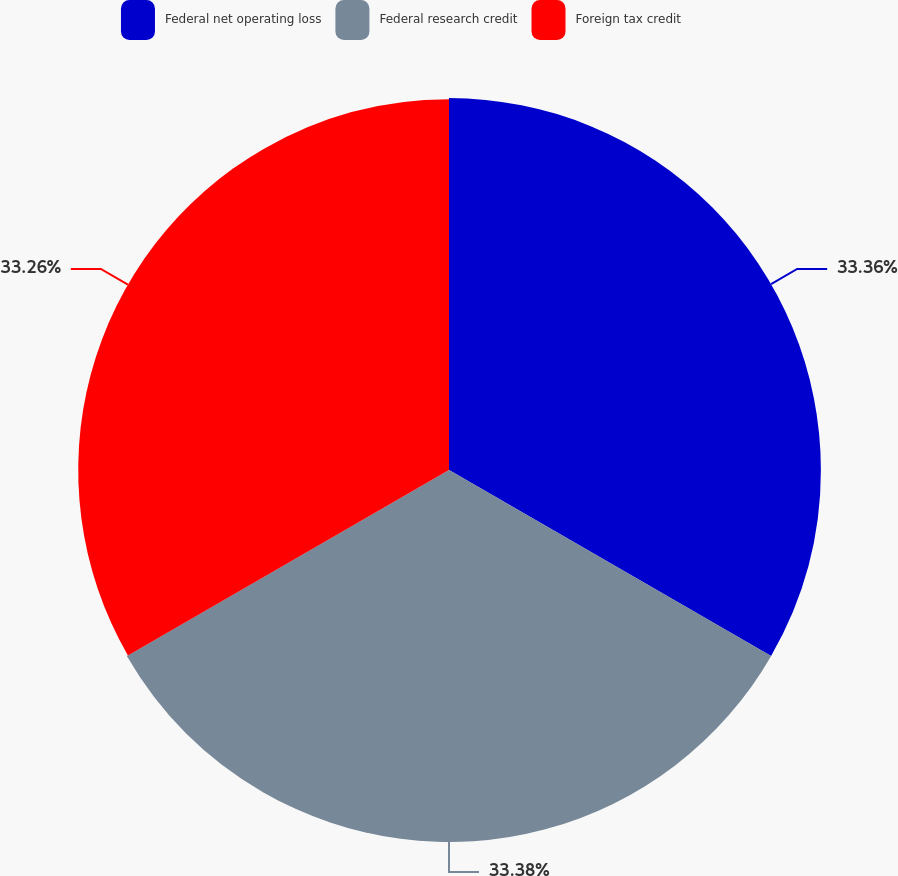<chart> <loc_0><loc_0><loc_500><loc_500><pie_chart><fcel>Federal net operating loss<fcel>Federal research credit<fcel>Foreign tax credit<nl><fcel>33.36%<fcel>33.37%<fcel>33.26%<nl></chart> 